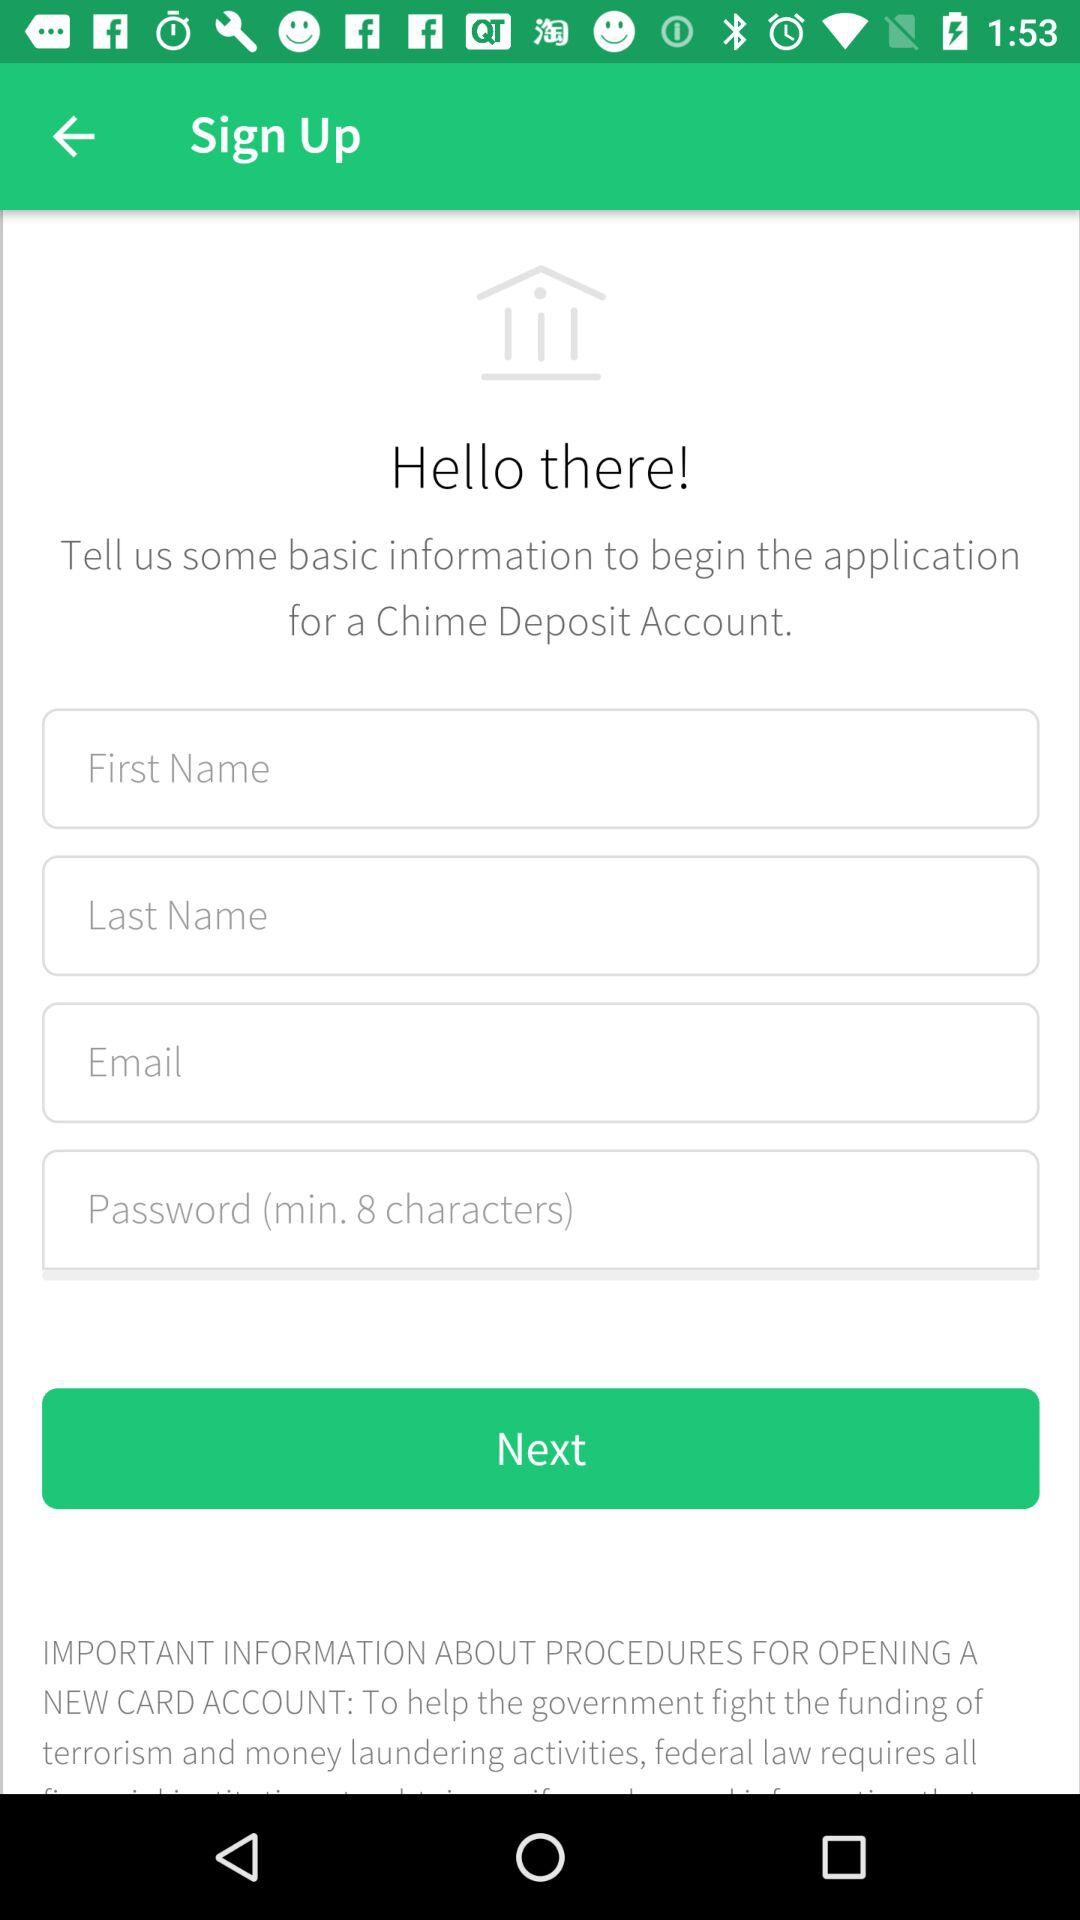What is the user's last name?
When the provided information is insufficient, respond with <no answer>. <no answer> 